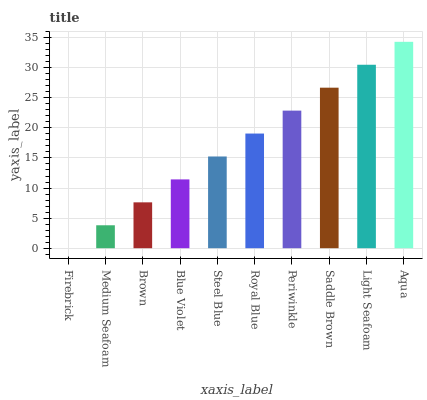Is Firebrick the minimum?
Answer yes or no. Yes. Is Aqua the maximum?
Answer yes or no. Yes. Is Medium Seafoam the minimum?
Answer yes or no. No. Is Medium Seafoam the maximum?
Answer yes or no. No. Is Medium Seafoam greater than Firebrick?
Answer yes or no. Yes. Is Firebrick less than Medium Seafoam?
Answer yes or no. Yes. Is Firebrick greater than Medium Seafoam?
Answer yes or no. No. Is Medium Seafoam less than Firebrick?
Answer yes or no. No. Is Royal Blue the high median?
Answer yes or no. Yes. Is Steel Blue the low median?
Answer yes or no. Yes. Is Firebrick the high median?
Answer yes or no. No. Is Firebrick the low median?
Answer yes or no. No. 